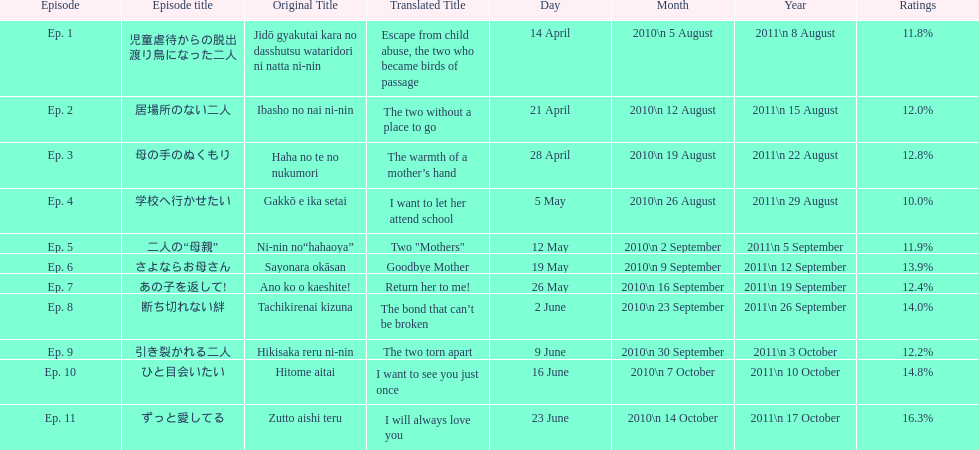What was the top rated episode of this show? ずっと愛してる. 